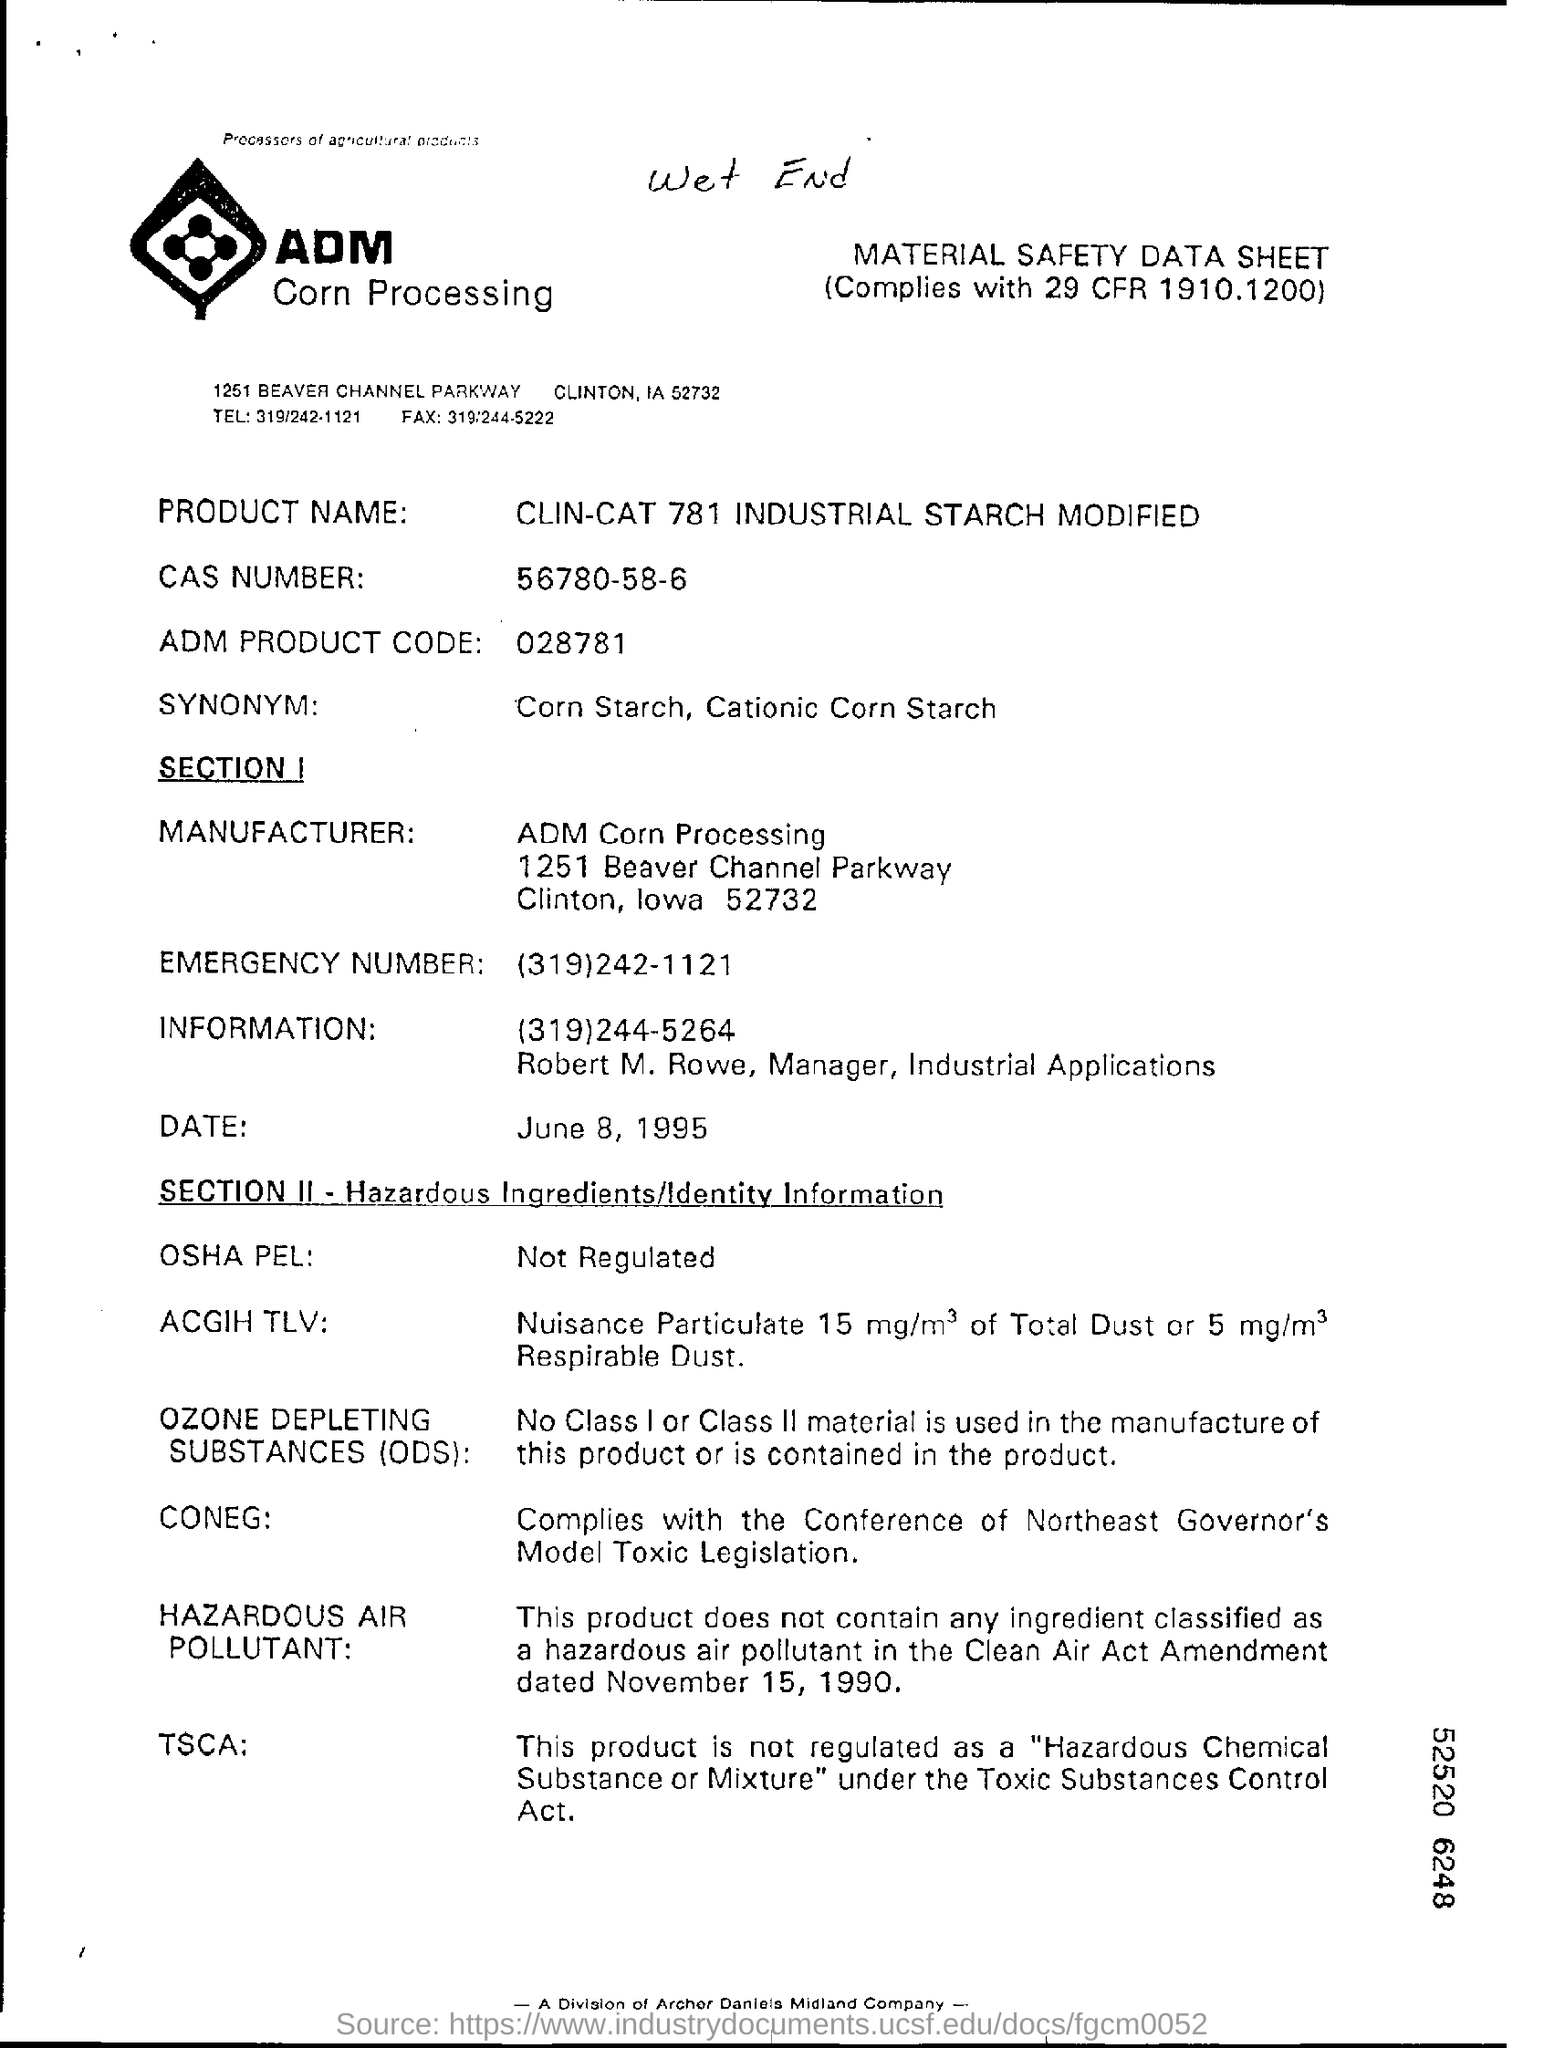Specify some key components in this picture. The document is written on top of a handwritten note that reads "wet end. 